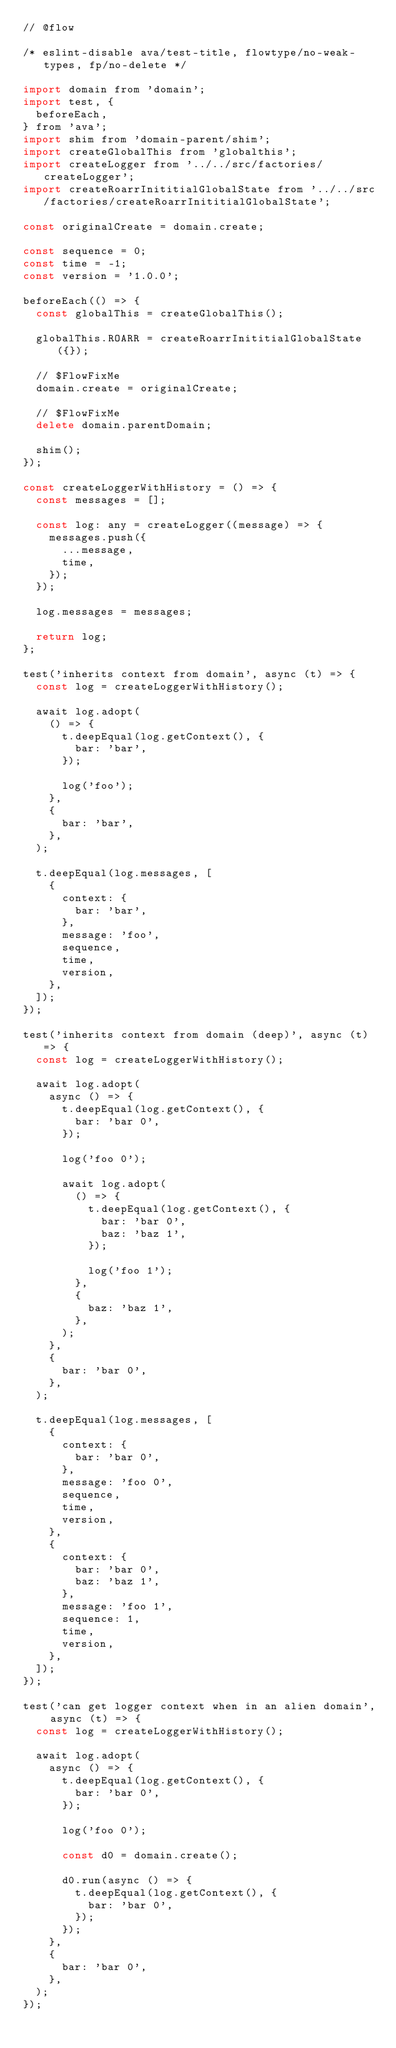<code> <loc_0><loc_0><loc_500><loc_500><_JavaScript_>// @flow

/* eslint-disable ava/test-title, flowtype/no-weak-types, fp/no-delete */

import domain from 'domain';
import test, {
  beforeEach,
} from 'ava';
import shim from 'domain-parent/shim';
import createGlobalThis from 'globalthis';
import createLogger from '../../src/factories/createLogger';
import createRoarrInititialGlobalState from '../../src/factories/createRoarrInititialGlobalState';

const originalCreate = domain.create;

const sequence = 0;
const time = -1;
const version = '1.0.0';

beforeEach(() => {
  const globalThis = createGlobalThis();

  globalThis.ROARR = createRoarrInititialGlobalState({});

  // $FlowFixMe
  domain.create = originalCreate;

  // $FlowFixMe
  delete domain.parentDomain;

  shim();
});

const createLoggerWithHistory = () => {
  const messages = [];

  const log: any = createLogger((message) => {
    messages.push({
      ...message,
      time,
    });
  });

  log.messages = messages;

  return log;
};

test('inherits context from domain', async (t) => {
  const log = createLoggerWithHistory();

  await log.adopt(
    () => {
      t.deepEqual(log.getContext(), {
        bar: 'bar',
      });

      log('foo');
    },
    {
      bar: 'bar',
    },
  );

  t.deepEqual(log.messages, [
    {
      context: {
        bar: 'bar',
      },
      message: 'foo',
      sequence,
      time,
      version,
    },
  ]);
});

test('inherits context from domain (deep)', async (t) => {
  const log = createLoggerWithHistory();

  await log.adopt(
    async () => {
      t.deepEqual(log.getContext(), {
        bar: 'bar 0',
      });

      log('foo 0');

      await log.adopt(
        () => {
          t.deepEqual(log.getContext(), {
            bar: 'bar 0',
            baz: 'baz 1',
          });

          log('foo 1');
        },
        {
          baz: 'baz 1',
        },
      );
    },
    {
      bar: 'bar 0',
    },
  );

  t.deepEqual(log.messages, [
    {
      context: {
        bar: 'bar 0',
      },
      message: 'foo 0',
      sequence,
      time,
      version,
    },
    {
      context: {
        bar: 'bar 0',
        baz: 'baz 1',
      },
      message: 'foo 1',
      sequence: 1,
      time,
      version,
    },
  ]);
});

test('can get logger context when in an alien domain', async (t) => {
  const log = createLoggerWithHistory();

  await log.adopt(
    async () => {
      t.deepEqual(log.getContext(), {
        bar: 'bar 0',
      });

      log('foo 0');

      const d0 = domain.create();

      d0.run(async () => {
        t.deepEqual(log.getContext(), {
          bar: 'bar 0',
        });
      });
    },
    {
      bar: 'bar 0',
    },
  );
});
</code> 